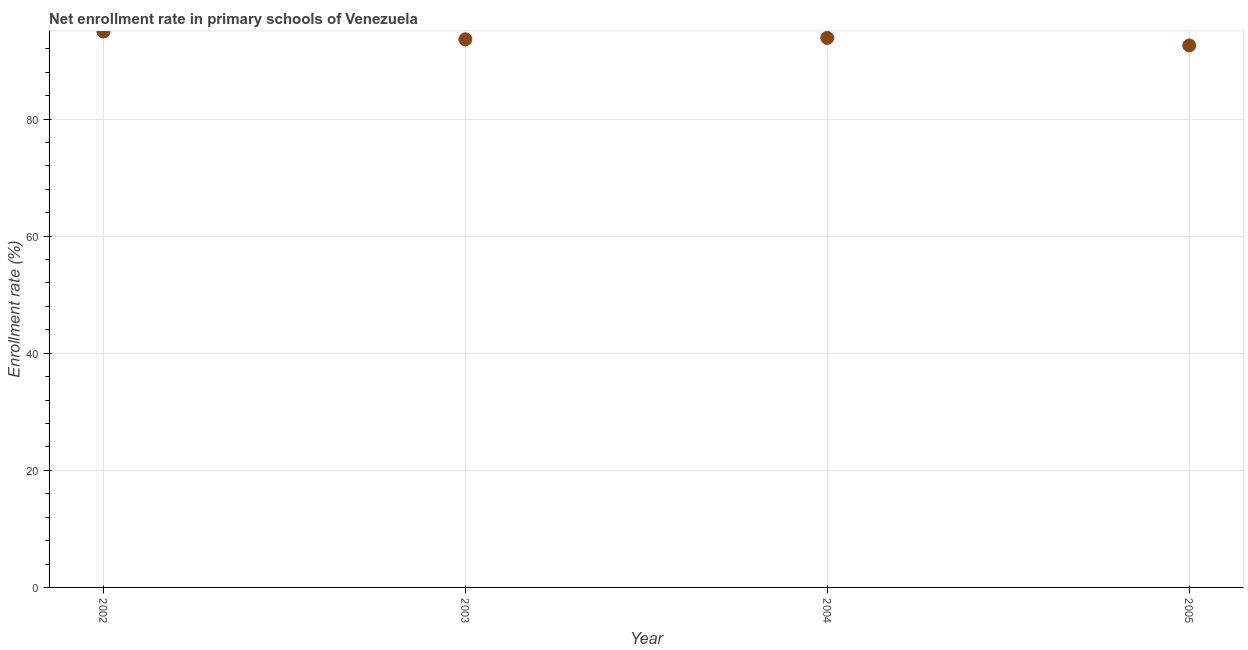What is the net enrollment rate in primary schools in 2005?
Your answer should be very brief. 92.57. Across all years, what is the maximum net enrollment rate in primary schools?
Keep it short and to the point. 94.95. Across all years, what is the minimum net enrollment rate in primary schools?
Provide a short and direct response. 92.57. What is the sum of the net enrollment rate in primary schools?
Keep it short and to the point. 375. What is the difference between the net enrollment rate in primary schools in 2002 and 2003?
Make the answer very short. 1.33. What is the average net enrollment rate in primary schools per year?
Offer a terse response. 93.75. What is the median net enrollment rate in primary schools?
Your response must be concise. 93.74. In how many years, is the net enrollment rate in primary schools greater than 72 %?
Provide a short and direct response. 4. Do a majority of the years between 2003 and 2002 (inclusive) have net enrollment rate in primary schools greater than 52 %?
Your response must be concise. No. What is the ratio of the net enrollment rate in primary schools in 2002 to that in 2004?
Your answer should be compact. 1.01. What is the difference between the highest and the second highest net enrollment rate in primary schools?
Offer a terse response. 1.09. Is the sum of the net enrollment rate in primary schools in 2003 and 2005 greater than the maximum net enrollment rate in primary schools across all years?
Keep it short and to the point. Yes. What is the difference between the highest and the lowest net enrollment rate in primary schools?
Give a very brief answer. 2.38. In how many years, is the net enrollment rate in primary schools greater than the average net enrollment rate in primary schools taken over all years?
Provide a short and direct response. 2. Does the net enrollment rate in primary schools monotonically increase over the years?
Keep it short and to the point. No. Does the graph contain any zero values?
Provide a succinct answer. No. What is the title of the graph?
Provide a succinct answer. Net enrollment rate in primary schools of Venezuela. What is the label or title of the X-axis?
Your answer should be compact. Year. What is the label or title of the Y-axis?
Your answer should be compact. Enrollment rate (%). What is the Enrollment rate (%) in 2002?
Give a very brief answer. 94.95. What is the Enrollment rate (%) in 2003?
Provide a succinct answer. 93.62. What is the Enrollment rate (%) in 2004?
Your answer should be very brief. 93.86. What is the Enrollment rate (%) in 2005?
Keep it short and to the point. 92.57. What is the difference between the Enrollment rate (%) in 2002 and 2003?
Keep it short and to the point. 1.33. What is the difference between the Enrollment rate (%) in 2002 and 2004?
Provide a succinct answer. 1.09. What is the difference between the Enrollment rate (%) in 2002 and 2005?
Your answer should be very brief. 2.38. What is the difference between the Enrollment rate (%) in 2003 and 2004?
Offer a very short reply. -0.24. What is the difference between the Enrollment rate (%) in 2003 and 2005?
Your answer should be compact. 1.05. What is the difference between the Enrollment rate (%) in 2004 and 2005?
Give a very brief answer. 1.29. What is the ratio of the Enrollment rate (%) in 2002 to that in 2004?
Your answer should be compact. 1.01. What is the ratio of the Enrollment rate (%) in 2002 to that in 2005?
Make the answer very short. 1.03. What is the ratio of the Enrollment rate (%) in 2003 to that in 2005?
Make the answer very short. 1.01. What is the ratio of the Enrollment rate (%) in 2004 to that in 2005?
Ensure brevity in your answer.  1.01. 